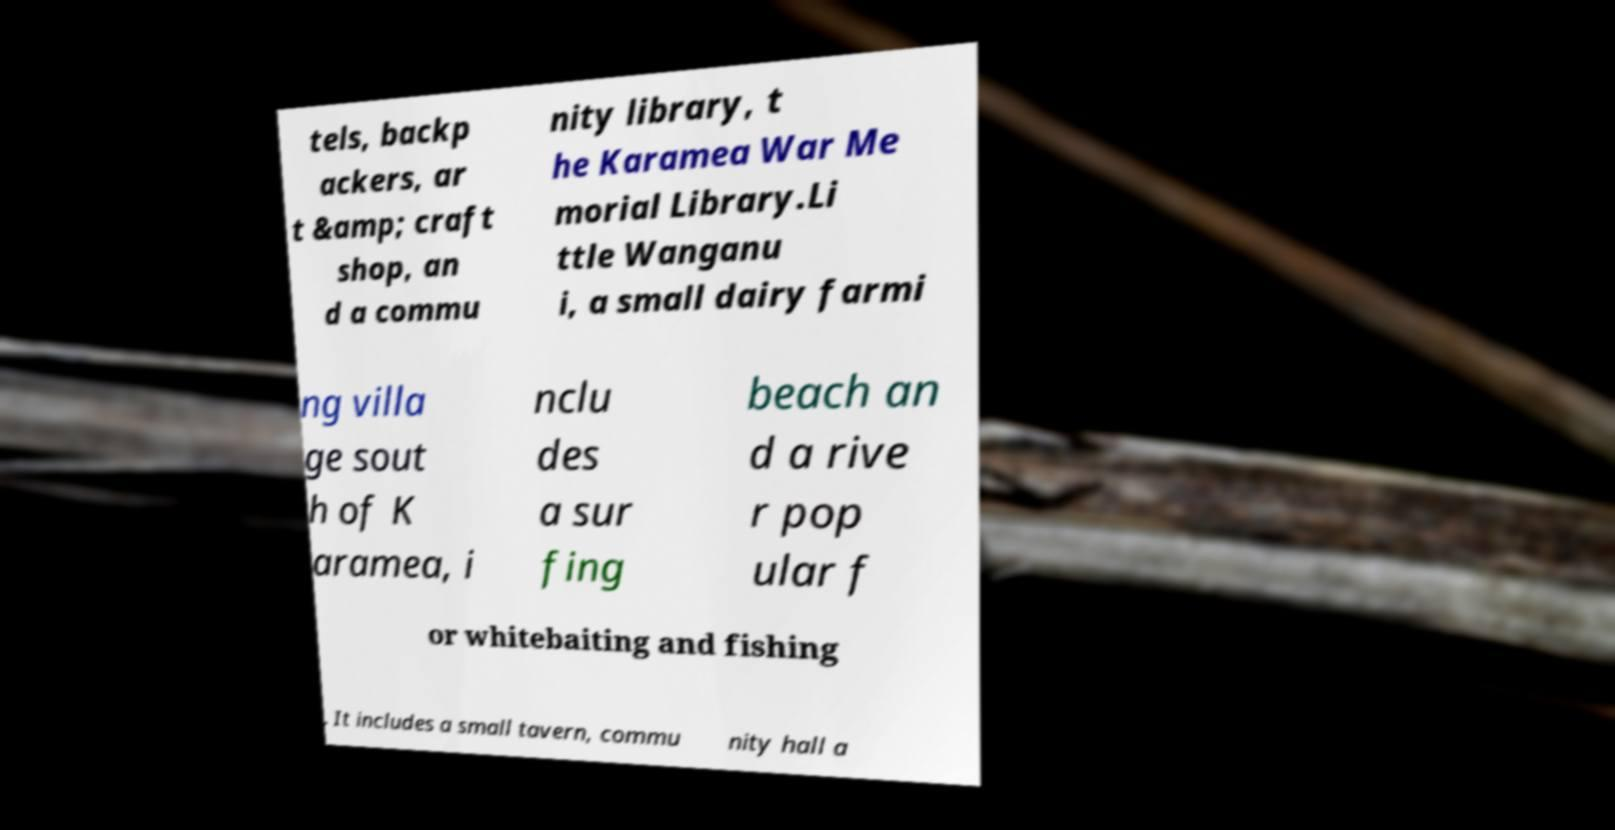I need the written content from this picture converted into text. Can you do that? tels, backp ackers, ar t &amp; craft shop, an d a commu nity library, t he Karamea War Me morial Library.Li ttle Wanganu i, a small dairy farmi ng villa ge sout h of K aramea, i nclu des a sur fing beach an d a rive r pop ular f or whitebaiting and fishing . It includes a small tavern, commu nity hall a 